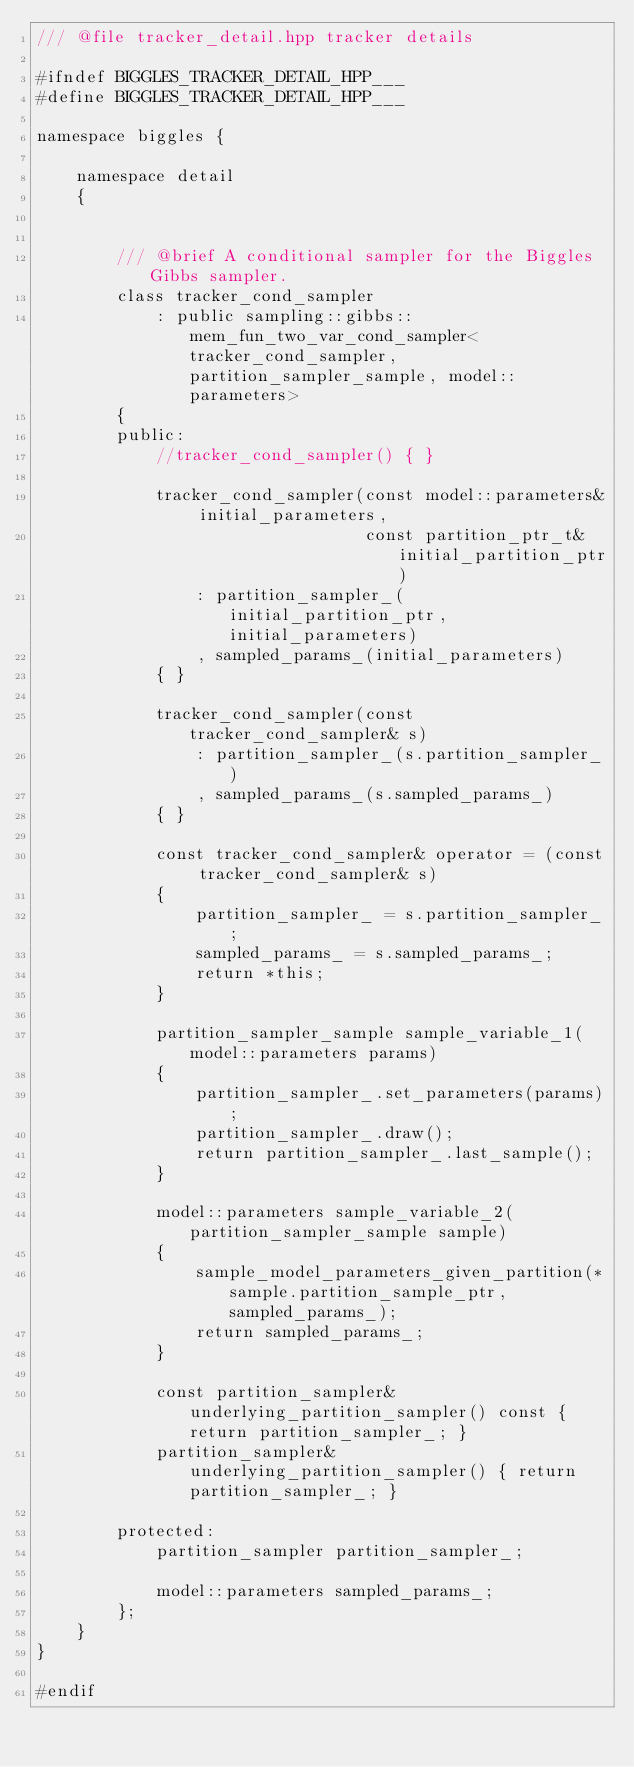<code> <loc_0><loc_0><loc_500><loc_500><_C++_>/// @file tracker_detail.hpp tracker details

#ifndef BIGGLES_TRACKER_DETAIL_HPP___
#define BIGGLES_TRACKER_DETAIL_HPP___

namespace biggles {

    namespace detail
    {


        /// @brief A conditional sampler for the Biggles Gibbs sampler.
        class tracker_cond_sampler
            : public sampling::gibbs::mem_fun_two_var_cond_sampler<tracker_cond_sampler, partition_sampler_sample, model::parameters>
        {
        public:
            //tracker_cond_sampler() { }

            tracker_cond_sampler(const model::parameters& initial_parameters,
                                 const partition_ptr_t& initial_partition_ptr)
                : partition_sampler_(initial_partition_ptr, initial_parameters)
                , sampled_params_(initial_parameters)
            { }

            tracker_cond_sampler(const tracker_cond_sampler& s)
                : partition_sampler_(s.partition_sampler_)
                , sampled_params_(s.sampled_params_)
            { }

            const tracker_cond_sampler& operator = (const tracker_cond_sampler& s)
            {
                partition_sampler_ = s.partition_sampler_;
                sampled_params_ = s.sampled_params_;
                return *this;
            }

            partition_sampler_sample sample_variable_1(model::parameters params)
            {
                partition_sampler_.set_parameters(params);
                partition_sampler_.draw();
                return partition_sampler_.last_sample();
            }

            model::parameters sample_variable_2(partition_sampler_sample sample)
            {
                sample_model_parameters_given_partition(*sample.partition_sample_ptr, sampled_params_);
                return sampled_params_;
            }

            const partition_sampler& underlying_partition_sampler() const { return partition_sampler_; }
            partition_sampler& underlying_partition_sampler() { return partition_sampler_; }

        protected:
            partition_sampler partition_sampler_;

            model::parameters sampled_params_;
        };
    }
}

#endif
</code> 